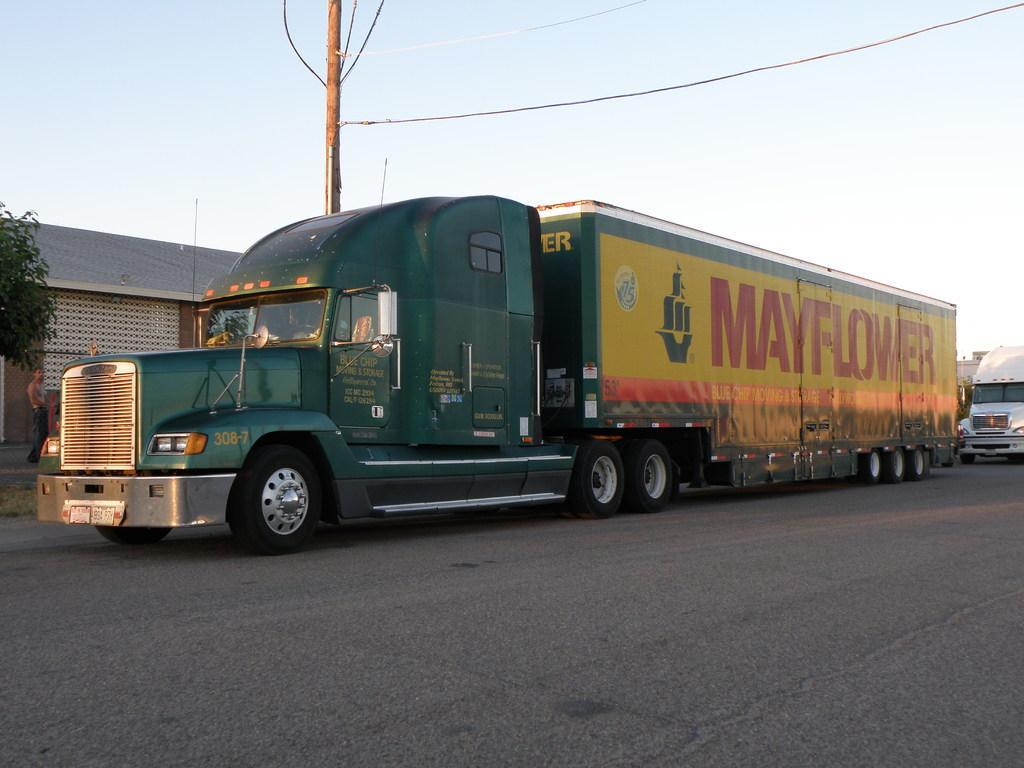Describe this image in one or two sentences. In the image we can see there are vehicles parked on the road and behind there is a building. There is an electrical wire pole. 